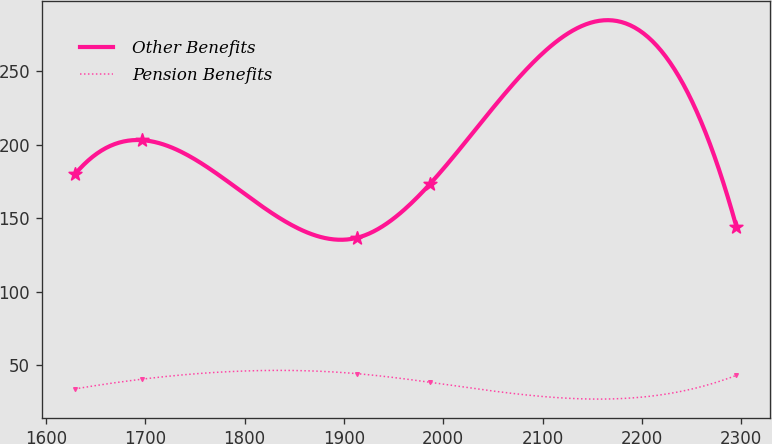<chart> <loc_0><loc_0><loc_500><loc_500><line_chart><ecel><fcel>Other Benefits<fcel>Pension Benefits<nl><fcel>1629.19<fcel>179.73<fcel>33.89<nl><fcel>1696.73<fcel>202.96<fcel>40.5<nl><fcel>1913.29<fcel>136.6<fcel>44.25<nl><fcel>1986.57<fcel>173.09<fcel>38.4<nl><fcel>2295.27<fcel>143.94<fcel>43.14<nl></chart> 